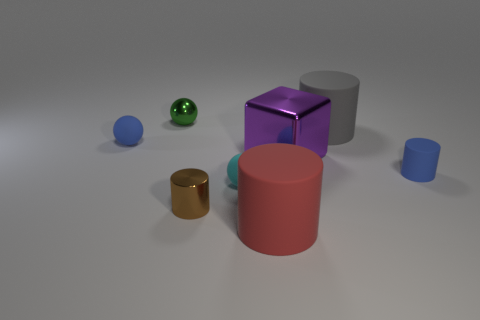Add 1 shiny objects. How many objects exist? 9 Subtract all small cyan matte balls. How many balls are left? 2 Subtract all blue cylinders. How many cylinders are left? 3 Add 1 large gray matte things. How many large gray matte things exist? 2 Subtract 0 yellow cylinders. How many objects are left? 8 Subtract all cubes. How many objects are left? 7 Subtract 1 spheres. How many spheres are left? 2 Subtract all blue cylinders. Subtract all gray blocks. How many cylinders are left? 3 Subtract all yellow balls. How many brown cylinders are left? 1 Subtract all tiny brown things. Subtract all big gray cylinders. How many objects are left? 6 